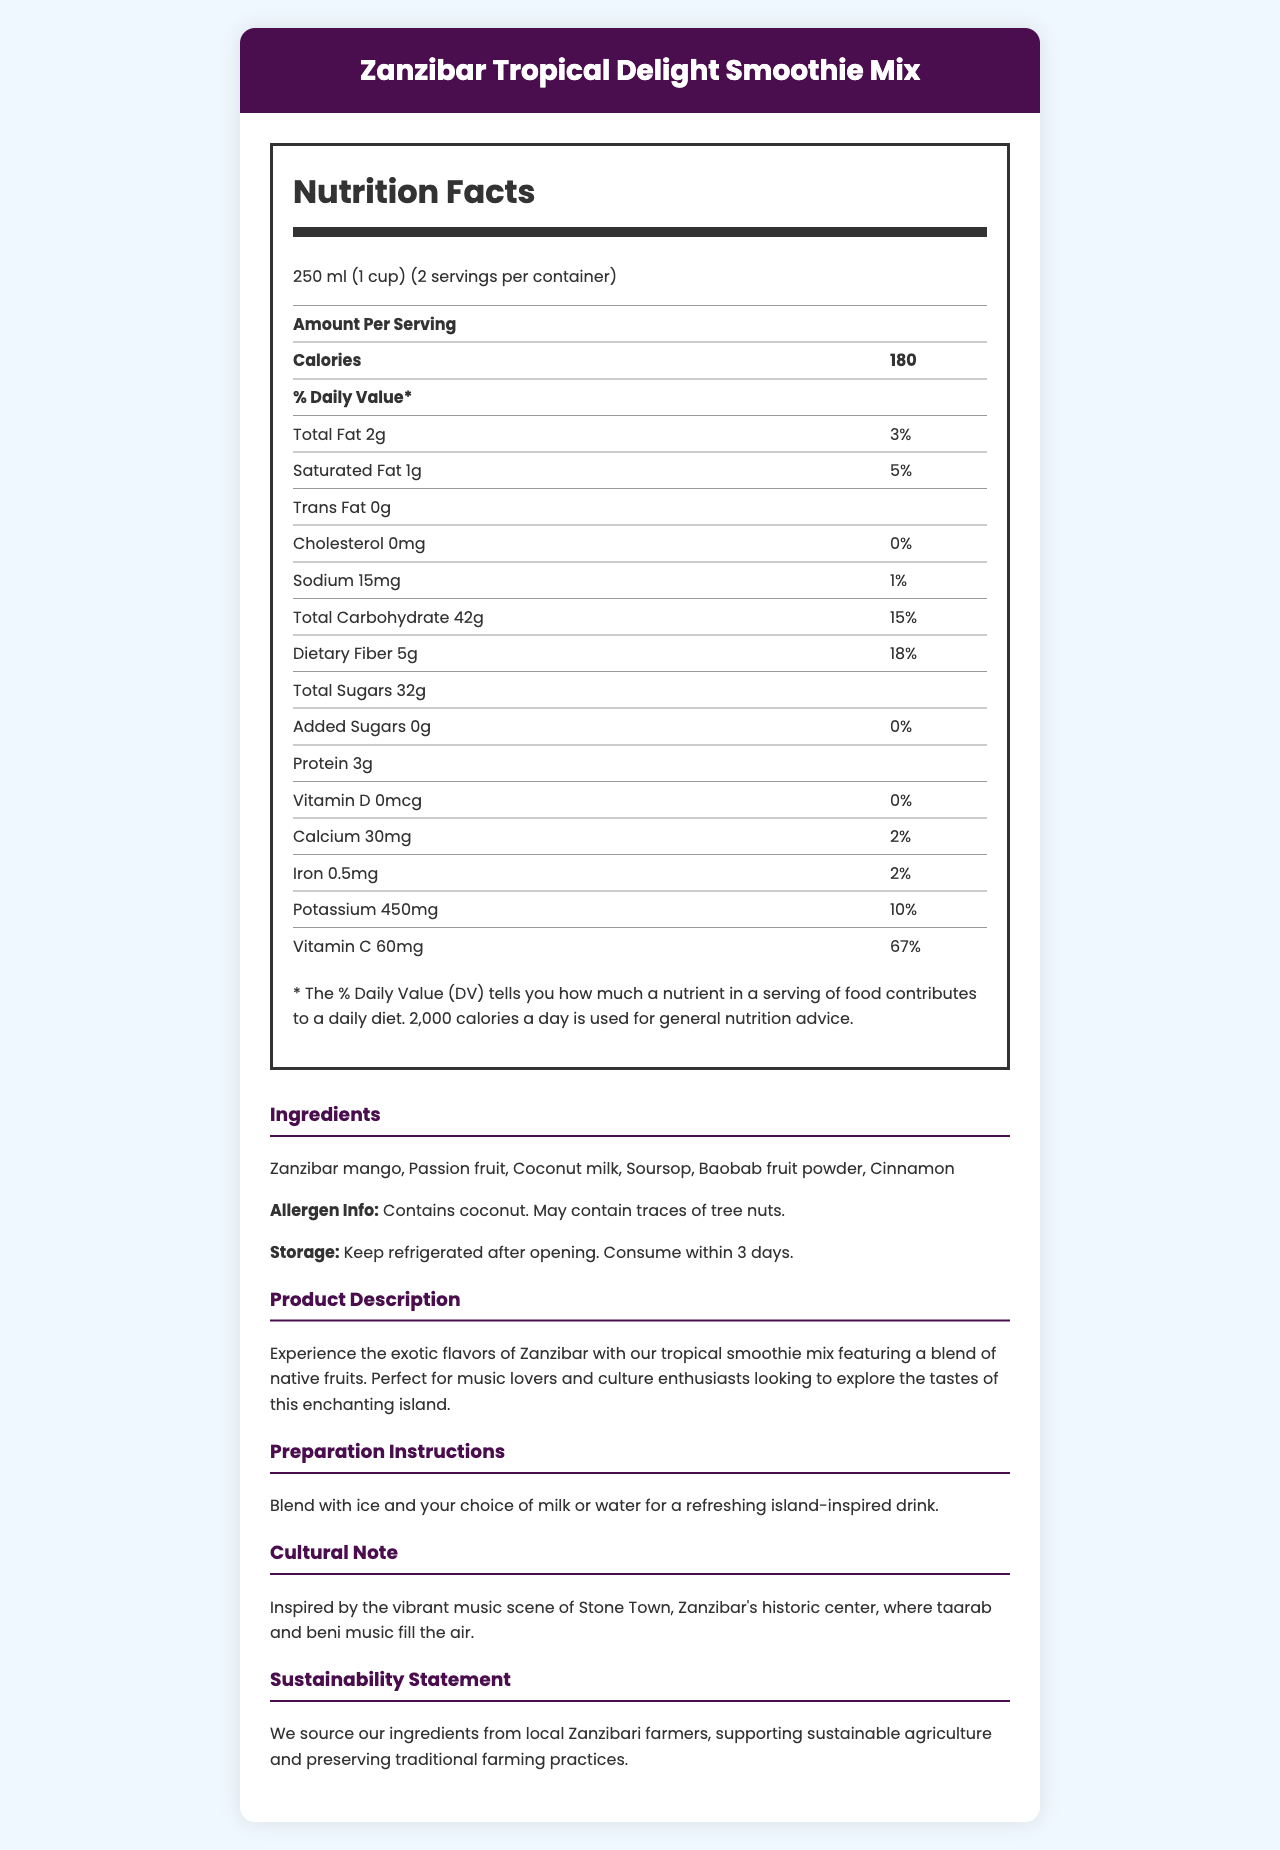what is the serving size? The serving size is clearly listed under Nutrition Facts as "250 ml (1 cup)".
Answer: 250 ml (1 cup) how many calories are in one serving? The number of calories per serving is specified as 180 in the Nutrition Facts section.
Answer: 180 what is the amount of potassium in one serving? The potassium content per serving is listed as 450mg in the Nutrition Facts section.
Answer: 450mg what percentage of the daily value of Vitamin C does one serving provide? The percentage of the daily value of Vitamin C provided is stated as 67% in the Nutrition Facts section.
Answer: 67% which ingredient in this smoothie mix might be an allergen? The document states that the product contains coconut and may contain traces of tree nuts, under Allergen Info.
Answer: Coconut what is unique about the cultural note provided? The cultural note ties the product to the music and culture of Zanzibar, specifically Stone Town.
Answer: It mentions the vibrant music scene of Stone Town, Zanzibar's historic center, where taarab and beni music fill the air. how many servings are in one container? A. 1 B. 2 C. 3 D. 4 The document states that there are 2 servings per container.
Answer: B. 2 how much dietary fiber is in one serving? A. 5g B. 18g C. 10g D. 42g The amount of dietary fiber per serving is listed as 5g in the Nutrition Facts section.
Answer: A. 5g does the smoothie mix contain any added sugars? The document states that added sugars amount to 0g.
Answer: No are there tree nuts in the smoothie mix? According to the allergen info, the product may contain traces of tree nuts.
Answer: May contain traces summarize the main idea of the document. The document aims to inform about the nutritional content, ingredients, cultural significance, and preparation of the Zanzibar Tropical Delight Smoothie Mix.
Answer: The document provides a detailed description of the Zanzibar Tropical Delight Smoothie Mix, including its nutrition facts, ingredients, allergen information, product description, preparation instructions, cultural note, and sustainability statement. where does the company source its ingredients? The sustainability statement mentions that the ingredients are sourced from local Zanzibari farmers.
Answer: From local Zanzibari farmers what is the tropical flavor base of the smoothie mix? These ingredients are listed under the Ingredients section.
Answer: Zanzibar mango, Passion fruit, Coconut milk, Soursop, Baobab fruit powder, and Cinnamon what time of music is popular in Stone Town, Zanzibar, mentioned in the cultural note? The cultural note section mentions taarab and beni music as popular in Stone Town, Zanzibar.
Answer: Taarab and beni music what is not mentioned about the smoothie mix? The document does not provide any information about the price of the smoothie mix.
Answer: The price 